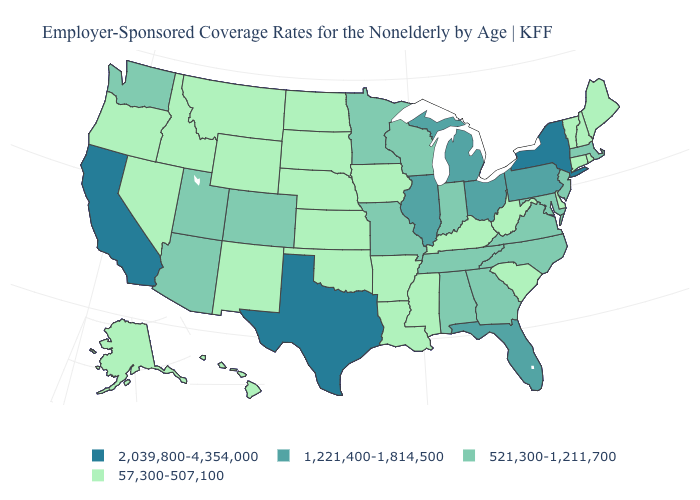Which states have the highest value in the USA?
Be succinct. California, New York, Texas. Among the states that border Oregon , which have the lowest value?
Give a very brief answer. Idaho, Nevada. How many symbols are there in the legend?
Quick response, please. 4. What is the value of Mississippi?
Keep it brief. 57,300-507,100. What is the value of Tennessee?
Write a very short answer. 521,300-1,211,700. Does Ohio have a higher value than Delaware?
Keep it brief. Yes. Which states have the highest value in the USA?
Give a very brief answer. California, New York, Texas. Which states have the lowest value in the USA?
Keep it brief. Alaska, Arkansas, Connecticut, Delaware, Hawaii, Idaho, Iowa, Kansas, Kentucky, Louisiana, Maine, Mississippi, Montana, Nebraska, Nevada, New Hampshire, New Mexico, North Dakota, Oklahoma, Oregon, Rhode Island, South Carolina, South Dakota, Vermont, West Virginia, Wyoming. Name the states that have a value in the range 521,300-1,211,700?
Keep it brief. Alabama, Arizona, Colorado, Georgia, Indiana, Maryland, Massachusetts, Minnesota, Missouri, New Jersey, North Carolina, Tennessee, Utah, Virginia, Washington, Wisconsin. Does Ohio have the highest value in the MidWest?
Answer briefly. Yes. What is the value of Tennessee?
Concise answer only. 521,300-1,211,700. Does Iowa have a lower value than Washington?
Write a very short answer. Yes. Does Utah have a higher value than Michigan?
Be succinct. No. What is the lowest value in the USA?
Give a very brief answer. 57,300-507,100. Name the states that have a value in the range 1,221,400-1,814,500?
Concise answer only. Florida, Illinois, Michigan, Ohio, Pennsylvania. 